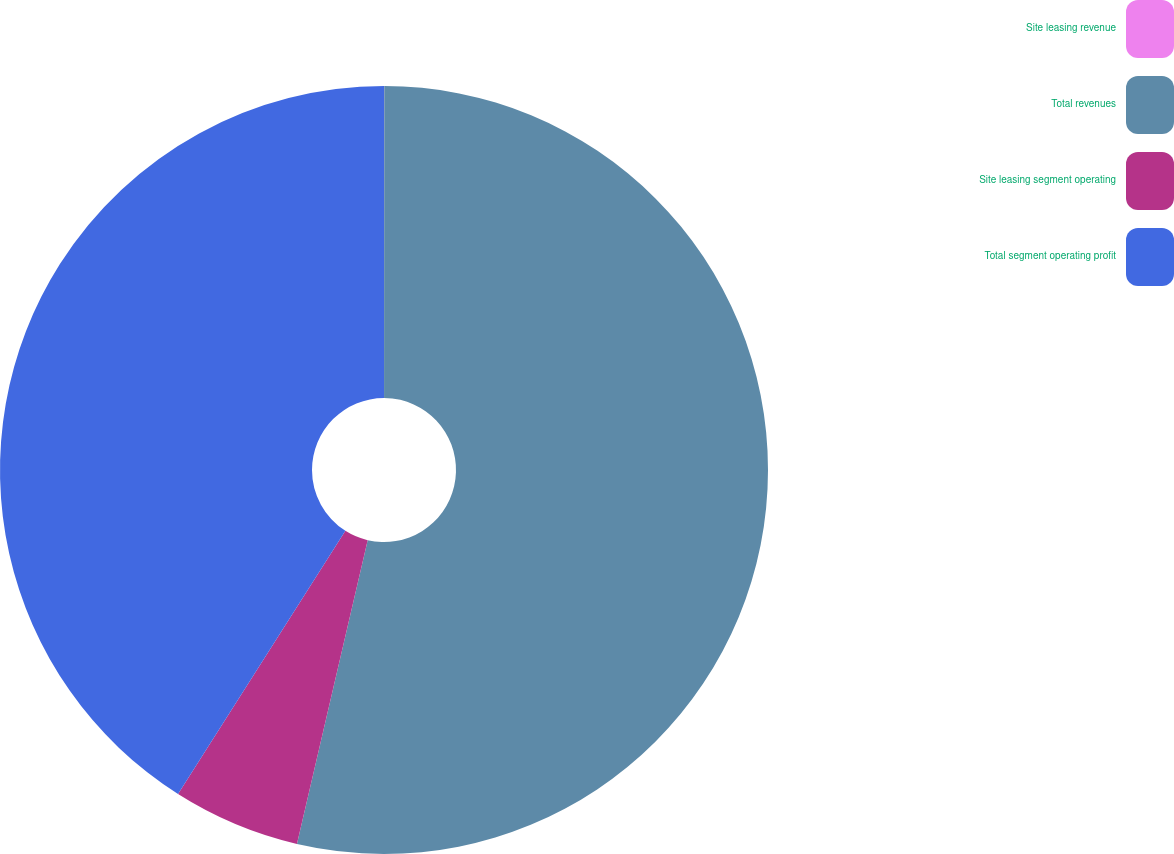<chart> <loc_0><loc_0><loc_500><loc_500><pie_chart><fcel>Site leasing revenue<fcel>Total revenues<fcel>Site leasing segment operating<fcel>Total segment operating profit<nl><fcel>0.01%<fcel>53.63%<fcel>5.37%<fcel>40.99%<nl></chart> 